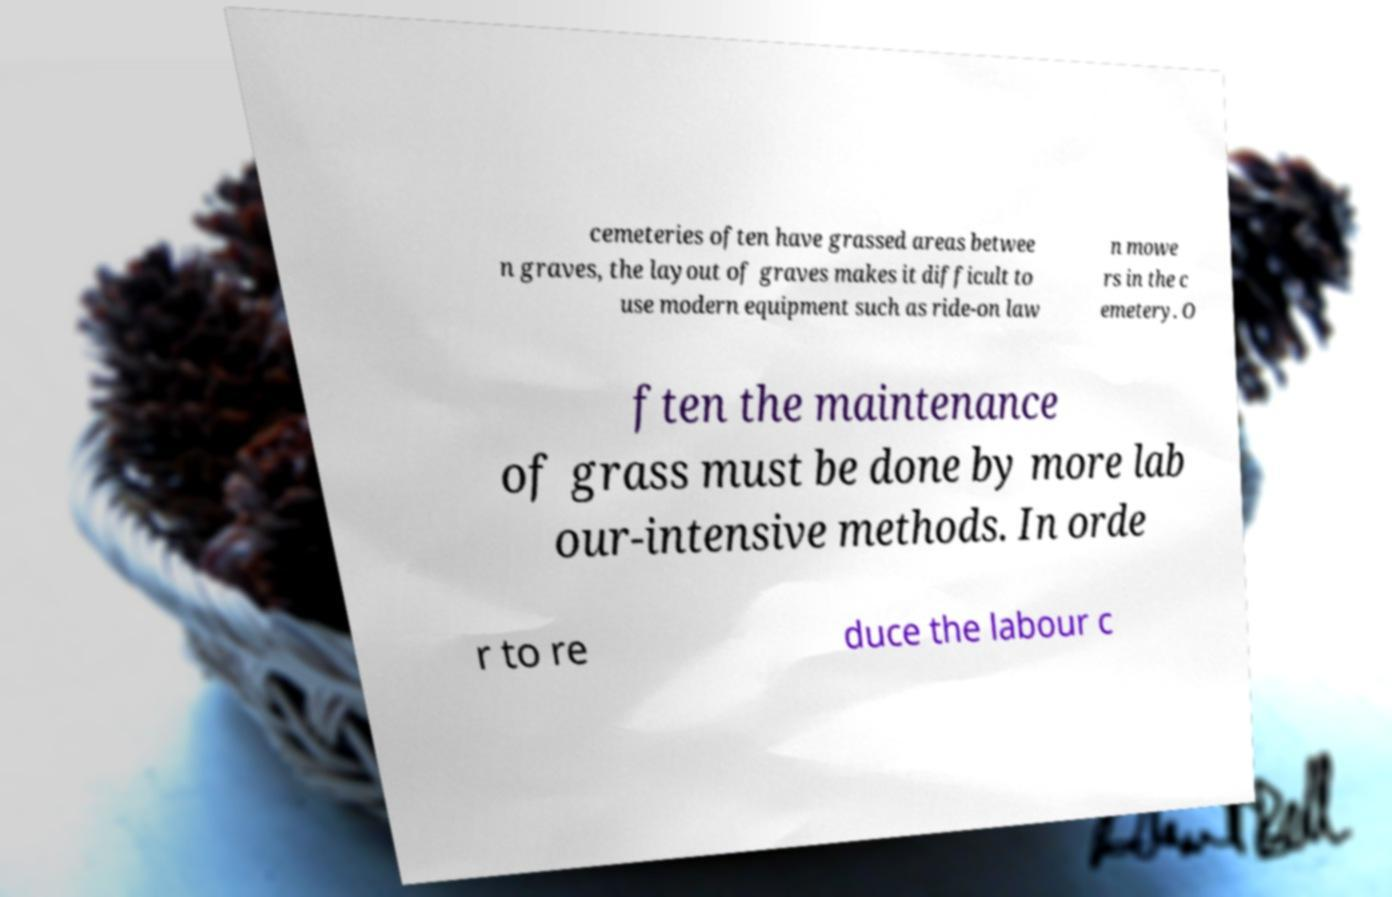Can you accurately transcribe the text from the provided image for me? cemeteries often have grassed areas betwee n graves, the layout of graves makes it difficult to use modern equipment such as ride-on law n mowe rs in the c emetery. O ften the maintenance of grass must be done by more lab our-intensive methods. In orde r to re duce the labour c 